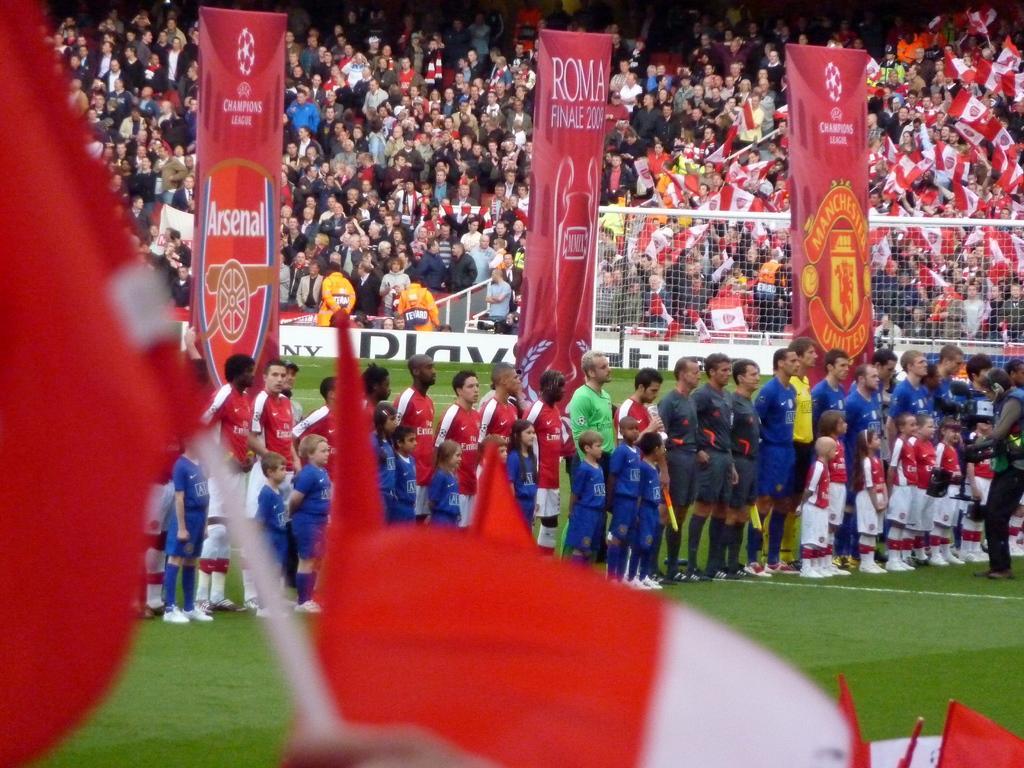Can you describe this image briefly? In this picture we can see a group of people are present. In the center of the image we can see a boards, mesh are there. On the right side of the image a person is holding a camera. At the bottom of the image ground is there. 